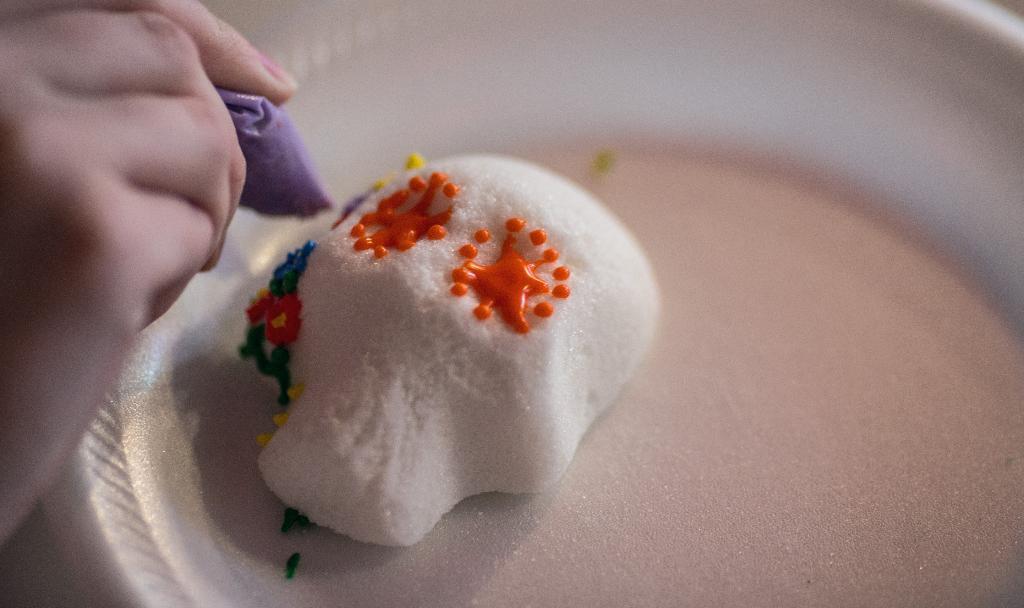Describe this image in one or two sentences. In this image there is a plate. There is an object on the plate. To the left there is a hand of a person. The person is holding an object in the hand. 